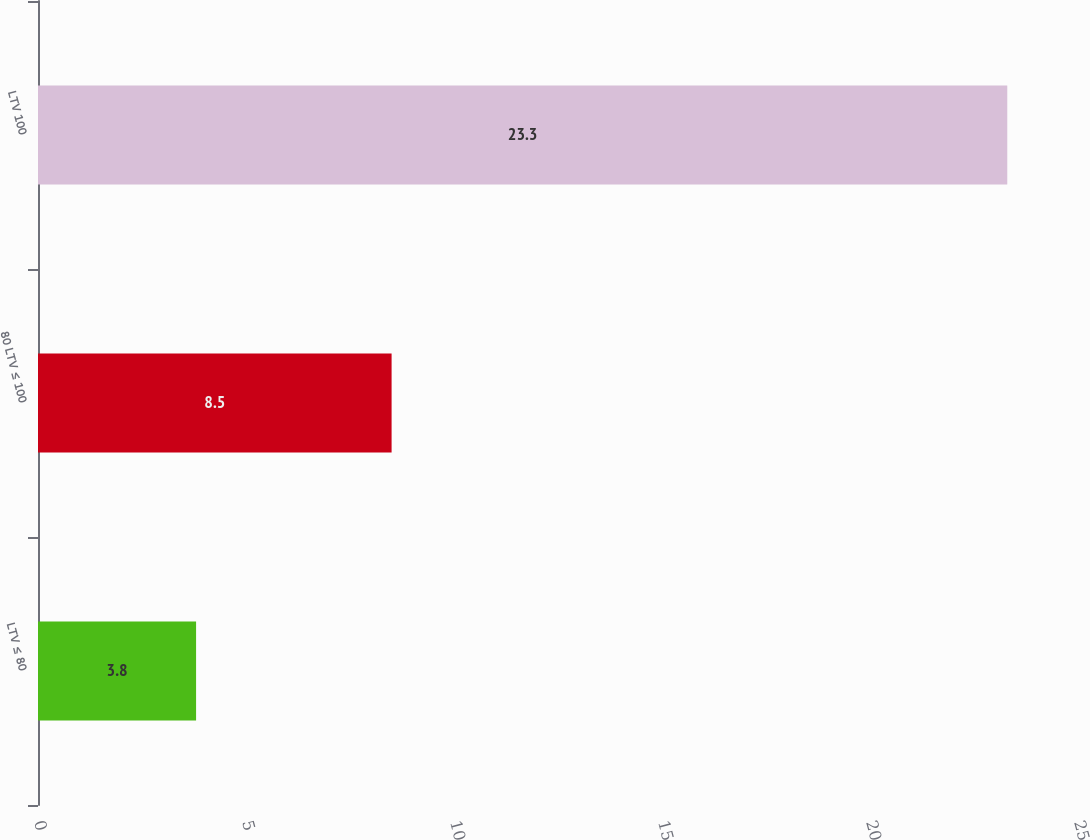Convert chart. <chart><loc_0><loc_0><loc_500><loc_500><bar_chart><fcel>LTV ≤ 80<fcel>80 LTV ≤ 100<fcel>LTV 100<nl><fcel>3.8<fcel>8.5<fcel>23.3<nl></chart> 